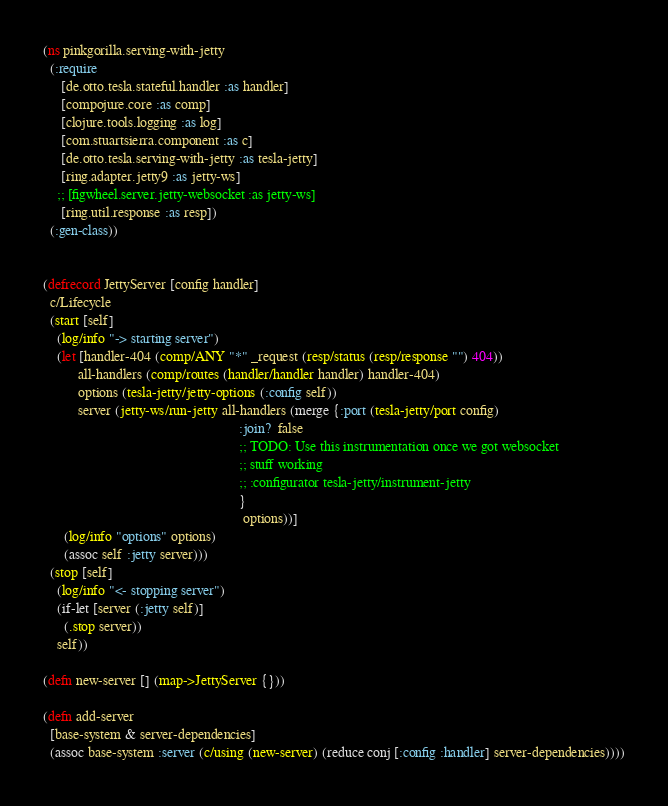<code> <loc_0><loc_0><loc_500><loc_500><_Clojure_>(ns pinkgorilla.serving-with-jetty
  (:require
     [de.otto.tesla.stateful.handler :as handler]
     [compojure.core :as comp]
     [clojure.tools.logging :as log]
     [com.stuartsierra.component :as c]
     [de.otto.tesla.serving-with-jetty :as tesla-jetty]
     [ring.adapter.jetty9 :as jetty-ws]
    ;; [figwheel.server.jetty-websocket :as jetty-ws]
     [ring.util.response :as resp])
  (:gen-class))


(defrecord JettyServer [config handler]
  c/Lifecycle
  (start [self]
    (log/info "-> starting server")
    (let [handler-404 (comp/ANY "*" _request (resp/status (resp/response "") 404))
          all-handlers (comp/routes (handler/handler handler) handler-404)
          options (tesla-jetty/jetty-options (:config self))
          server (jetty-ws/run-jetty all-handlers (merge {:port (tesla-jetty/port config)
                                                        :join?  false
                                                        ;; TODO: Use this instrumentation once we got websocket
                                                        ;; stuff working
                                                        ;; :configurator tesla-jetty/instrument-jetty
                                                        }
                                                         options))]
      (log/info "options" options)
      (assoc self :jetty server)))
  (stop [self]
    (log/info "<- stopping server")
    (if-let [server (:jetty self)]
      (.stop server))
    self))

(defn new-server [] (map->JettyServer {}))

(defn add-server
  [base-system & server-dependencies]
  (assoc base-system :server (c/using (new-server) (reduce conj [:config :handler] server-dependencies))))
</code> 